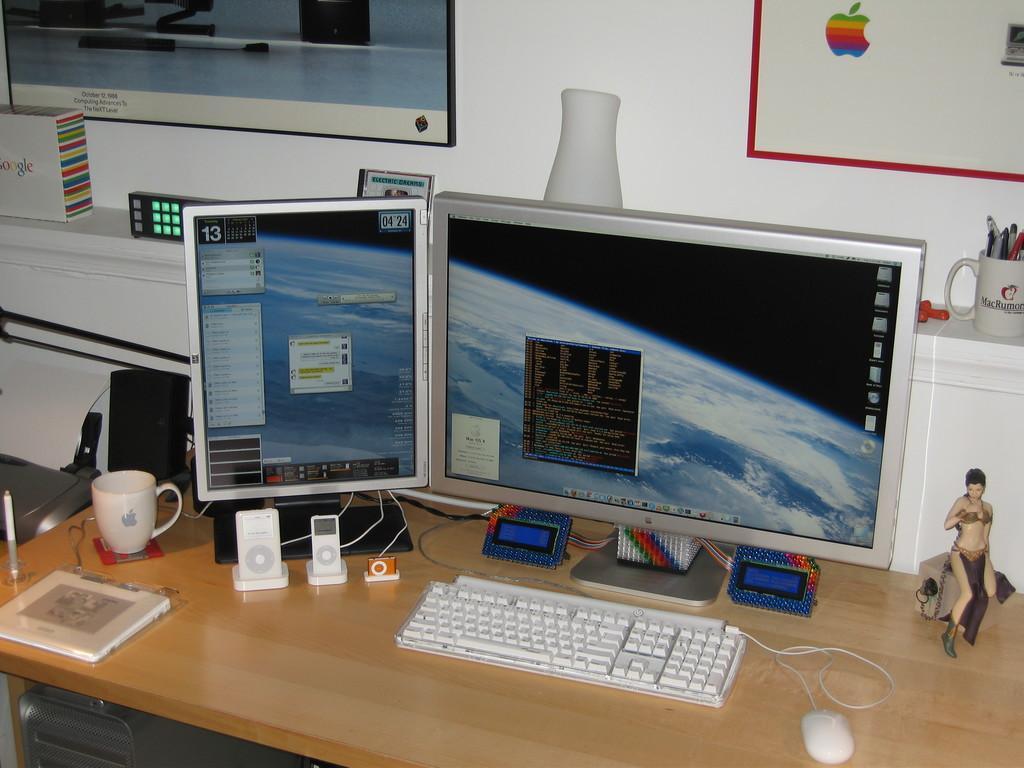Could you give a brief overview of what you see in this image? In this image there are two monitors on a table. Keyboard, mouse, cup, and few electrical devices on a table. To the right side of image there is a cup having pins in it. To the wall there is picture frames and a box at the left side of image text written as google. 